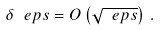<formula> <loc_0><loc_0><loc_500><loc_500>\delta _ { \ } e p s = O \left ( \sqrt { \ e p s } \right ) \, .</formula> 